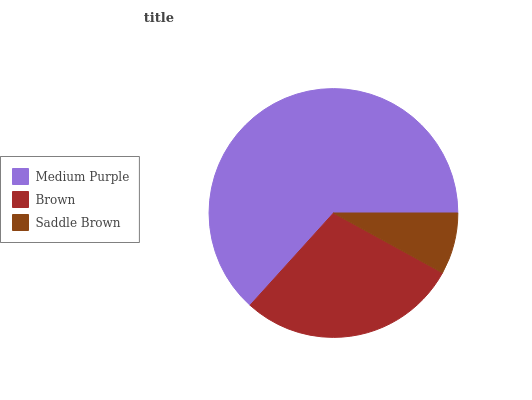Is Saddle Brown the minimum?
Answer yes or no. Yes. Is Medium Purple the maximum?
Answer yes or no. Yes. Is Brown the minimum?
Answer yes or no. No. Is Brown the maximum?
Answer yes or no. No. Is Medium Purple greater than Brown?
Answer yes or no. Yes. Is Brown less than Medium Purple?
Answer yes or no. Yes. Is Brown greater than Medium Purple?
Answer yes or no. No. Is Medium Purple less than Brown?
Answer yes or no. No. Is Brown the high median?
Answer yes or no. Yes. Is Brown the low median?
Answer yes or no. Yes. Is Medium Purple the high median?
Answer yes or no. No. Is Saddle Brown the low median?
Answer yes or no. No. 